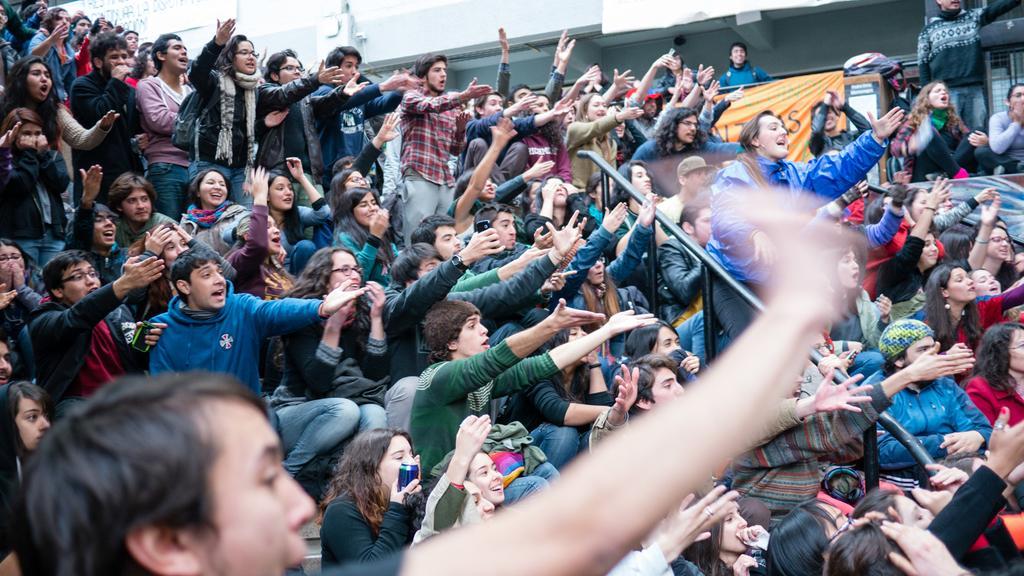In one or two sentences, can you explain what this image depicts? In this image I can see group of people. In the background I can see a banner and some other objects. 